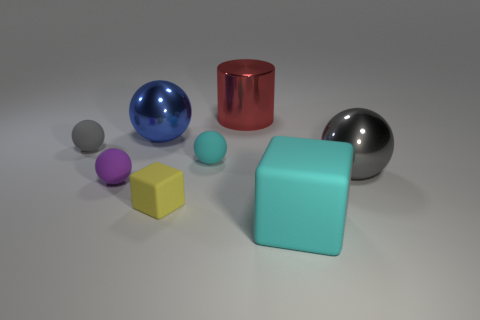Subtract all big gray balls. How many balls are left? 4 Subtract all cyan balls. How many balls are left? 4 Subtract all red balls. Subtract all red cylinders. How many balls are left? 5 Add 2 purple rubber balls. How many objects exist? 10 Subtract all blocks. How many objects are left? 6 Subtract 1 purple balls. How many objects are left? 7 Subtract all purple shiny spheres. Subtract all large cyan things. How many objects are left? 7 Add 6 red things. How many red things are left? 7 Add 4 big brown matte spheres. How many big brown matte spheres exist? 4 